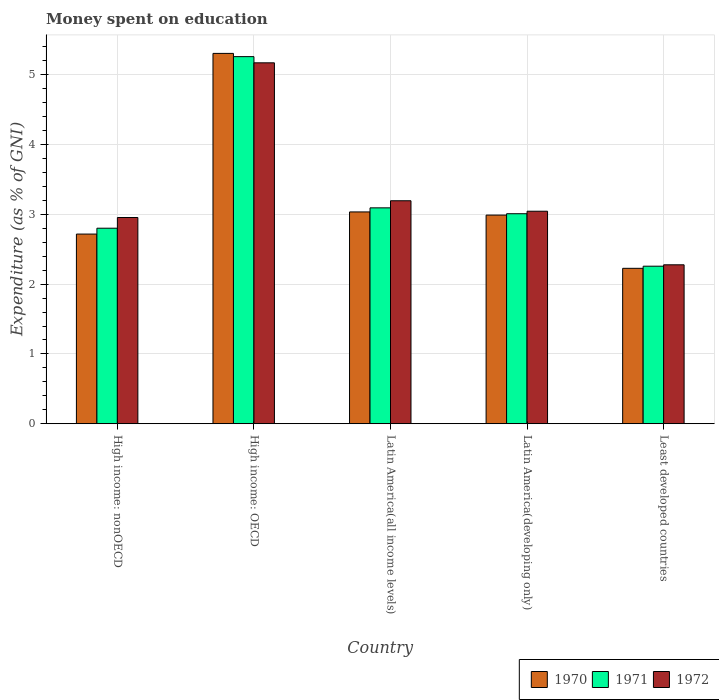How many different coloured bars are there?
Ensure brevity in your answer.  3. How many groups of bars are there?
Give a very brief answer. 5. How many bars are there on the 1st tick from the left?
Provide a succinct answer. 3. How many bars are there on the 3rd tick from the right?
Provide a short and direct response. 3. What is the label of the 1st group of bars from the left?
Provide a short and direct response. High income: nonOECD. What is the amount of money spent on education in 1972 in High income: nonOECD?
Give a very brief answer. 2.96. Across all countries, what is the maximum amount of money spent on education in 1972?
Your answer should be very brief. 5.17. Across all countries, what is the minimum amount of money spent on education in 1972?
Give a very brief answer. 2.28. In which country was the amount of money spent on education in 1972 maximum?
Give a very brief answer. High income: OECD. In which country was the amount of money spent on education in 1970 minimum?
Provide a succinct answer. Least developed countries. What is the total amount of money spent on education in 1971 in the graph?
Your answer should be very brief. 16.42. What is the difference between the amount of money spent on education in 1972 in High income: OECD and that in Latin America(all income levels)?
Your response must be concise. 1.98. What is the difference between the amount of money spent on education in 1972 in Latin America(all income levels) and the amount of money spent on education in 1971 in Least developed countries?
Make the answer very short. 0.94. What is the average amount of money spent on education in 1972 per country?
Provide a succinct answer. 3.33. What is the difference between the amount of money spent on education of/in 1970 and amount of money spent on education of/in 1971 in High income: nonOECD?
Keep it short and to the point. -0.08. In how many countries, is the amount of money spent on education in 1972 greater than 3.2 %?
Ensure brevity in your answer.  1. What is the ratio of the amount of money spent on education in 1972 in High income: OECD to that in Latin America(developing only)?
Your response must be concise. 1.7. Is the amount of money spent on education in 1970 in High income: OECD less than that in High income: nonOECD?
Give a very brief answer. No. What is the difference between the highest and the second highest amount of money spent on education in 1970?
Provide a succinct answer. -0.05. What is the difference between the highest and the lowest amount of money spent on education in 1972?
Offer a terse response. 2.89. In how many countries, is the amount of money spent on education in 1970 greater than the average amount of money spent on education in 1970 taken over all countries?
Offer a terse response. 1. What does the 1st bar from the right in High income: OECD represents?
Keep it short and to the point. 1972. How many bars are there?
Ensure brevity in your answer.  15. How many countries are there in the graph?
Provide a succinct answer. 5. Are the values on the major ticks of Y-axis written in scientific E-notation?
Your answer should be very brief. No. Does the graph contain any zero values?
Give a very brief answer. No. Does the graph contain grids?
Give a very brief answer. Yes. Where does the legend appear in the graph?
Your answer should be compact. Bottom right. How many legend labels are there?
Ensure brevity in your answer.  3. What is the title of the graph?
Provide a short and direct response. Money spent on education. What is the label or title of the Y-axis?
Offer a very short reply. Expenditure (as % of GNI). What is the Expenditure (as % of GNI) in 1970 in High income: nonOECD?
Give a very brief answer. 2.72. What is the Expenditure (as % of GNI) in 1971 in High income: nonOECD?
Your answer should be compact. 2.8. What is the Expenditure (as % of GNI) of 1972 in High income: nonOECD?
Your response must be concise. 2.96. What is the Expenditure (as % of GNI) of 1970 in High income: OECD?
Your answer should be compact. 5.31. What is the Expenditure (as % of GNI) of 1971 in High income: OECD?
Keep it short and to the point. 5.26. What is the Expenditure (as % of GNI) of 1972 in High income: OECD?
Offer a very short reply. 5.17. What is the Expenditure (as % of GNI) in 1970 in Latin America(all income levels)?
Ensure brevity in your answer.  3.04. What is the Expenditure (as % of GNI) in 1971 in Latin America(all income levels)?
Give a very brief answer. 3.09. What is the Expenditure (as % of GNI) of 1972 in Latin America(all income levels)?
Provide a short and direct response. 3.2. What is the Expenditure (as % of GNI) of 1970 in Latin America(developing only)?
Offer a very short reply. 2.99. What is the Expenditure (as % of GNI) in 1971 in Latin America(developing only)?
Provide a succinct answer. 3.01. What is the Expenditure (as % of GNI) in 1972 in Latin America(developing only)?
Keep it short and to the point. 3.05. What is the Expenditure (as % of GNI) in 1970 in Least developed countries?
Give a very brief answer. 2.23. What is the Expenditure (as % of GNI) of 1971 in Least developed countries?
Your answer should be very brief. 2.26. What is the Expenditure (as % of GNI) in 1972 in Least developed countries?
Give a very brief answer. 2.28. Across all countries, what is the maximum Expenditure (as % of GNI) in 1970?
Provide a succinct answer. 5.31. Across all countries, what is the maximum Expenditure (as % of GNI) of 1971?
Your answer should be very brief. 5.26. Across all countries, what is the maximum Expenditure (as % of GNI) in 1972?
Offer a very short reply. 5.17. Across all countries, what is the minimum Expenditure (as % of GNI) in 1970?
Your answer should be compact. 2.23. Across all countries, what is the minimum Expenditure (as % of GNI) of 1971?
Give a very brief answer. 2.26. Across all countries, what is the minimum Expenditure (as % of GNI) in 1972?
Your answer should be compact. 2.28. What is the total Expenditure (as % of GNI) of 1970 in the graph?
Provide a short and direct response. 16.28. What is the total Expenditure (as % of GNI) in 1971 in the graph?
Offer a very short reply. 16.42. What is the total Expenditure (as % of GNI) in 1972 in the graph?
Your response must be concise. 16.64. What is the difference between the Expenditure (as % of GNI) in 1970 in High income: nonOECD and that in High income: OECD?
Your response must be concise. -2.59. What is the difference between the Expenditure (as % of GNI) in 1971 in High income: nonOECD and that in High income: OECD?
Provide a succinct answer. -2.46. What is the difference between the Expenditure (as % of GNI) of 1972 in High income: nonOECD and that in High income: OECD?
Ensure brevity in your answer.  -2.22. What is the difference between the Expenditure (as % of GNI) of 1970 in High income: nonOECD and that in Latin America(all income levels)?
Your answer should be compact. -0.32. What is the difference between the Expenditure (as % of GNI) of 1971 in High income: nonOECD and that in Latin America(all income levels)?
Provide a succinct answer. -0.29. What is the difference between the Expenditure (as % of GNI) in 1972 in High income: nonOECD and that in Latin America(all income levels)?
Offer a very short reply. -0.24. What is the difference between the Expenditure (as % of GNI) in 1970 in High income: nonOECD and that in Latin America(developing only)?
Give a very brief answer. -0.27. What is the difference between the Expenditure (as % of GNI) of 1971 in High income: nonOECD and that in Latin America(developing only)?
Your answer should be compact. -0.21. What is the difference between the Expenditure (as % of GNI) of 1972 in High income: nonOECD and that in Latin America(developing only)?
Your answer should be very brief. -0.09. What is the difference between the Expenditure (as % of GNI) in 1970 in High income: nonOECD and that in Least developed countries?
Offer a very short reply. 0.49. What is the difference between the Expenditure (as % of GNI) in 1971 in High income: nonOECD and that in Least developed countries?
Offer a very short reply. 0.54. What is the difference between the Expenditure (as % of GNI) of 1972 in High income: nonOECD and that in Least developed countries?
Provide a short and direct response. 0.68. What is the difference between the Expenditure (as % of GNI) of 1970 in High income: OECD and that in Latin America(all income levels)?
Provide a short and direct response. 2.27. What is the difference between the Expenditure (as % of GNI) of 1971 in High income: OECD and that in Latin America(all income levels)?
Your answer should be very brief. 2.17. What is the difference between the Expenditure (as % of GNI) of 1972 in High income: OECD and that in Latin America(all income levels)?
Provide a succinct answer. 1.98. What is the difference between the Expenditure (as % of GNI) in 1970 in High income: OECD and that in Latin America(developing only)?
Your answer should be compact. 2.32. What is the difference between the Expenditure (as % of GNI) of 1971 in High income: OECD and that in Latin America(developing only)?
Offer a very short reply. 2.25. What is the difference between the Expenditure (as % of GNI) of 1972 in High income: OECD and that in Latin America(developing only)?
Offer a terse response. 2.13. What is the difference between the Expenditure (as % of GNI) in 1970 in High income: OECD and that in Least developed countries?
Give a very brief answer. 3.08. What is the difference between the Expenditure (as % of GNI) in 1971 in High income: OECD and that in Least developed countries?
Your answer should be compact. 3. What is the difference between the Expenditure (as % of GNI) in 1972 in High income: OECD and that in Least developed countries?
Provide a succinct answer. 2.89. What is the difference between the Expenditure (as % of GNI) in 1970 in Latin America(all income levels) and that in Latin America(developing only)?
Your response must be concise. 0.05. What is the difference between the Expenditure (as % of GNI) of 1971 in Latin America(all income levels) and that in Latin America(developing only)?
Offer a terse response. 0.08. What is the difference between the Expenditure (as % of GNI) in 1972 in Latin America(all income levels) and that in Latin America(developing only)?
Your response must be concise. 0.15. What is the difference between the Expenditure (as % of GNI) in 1970 in Latin America(all income levels) and that in Least developed countries?
Provide a short and direct response. 0.81. What is the difference between the Expenditure (as % of GNI) of 1971 in Latin America(all income levels) and that in Least developed countries?
Provide a short and direct response. 0.84. What is the difference between the Expenditure (as % of GNI) in 1972 in Latin America(all income levels) and that in Least developed countries?
Keep it short and to the point. 0.92. What is the difference between the Expenditure (as % of GNI) of 1970 in Latin America(developing only) and that in Least developed countries?
Give a very brief answer. 0.76. What is the difference between the Expenditure (as % of GNI) in 1971 in Latin America(developing only) and that in Least developed countries?
Make the answer very short. 0.75. What is the difference between the Expenditure (as % of GNI) of 1972 in Latin America(developing only) and that in Least developed countries?
Provide a short and direct response. 0.77. What is the difference between the Expenditure (as % of GNI) in 1970 in High income: nonOECD and the Expenditure (as % of GNI) in 1971 in High income: OECD?
Ensure brevity in your answer.  -2.54. What is the difference between the Expenditure (as % of GNI) of 1970 in High income: nonOECD and the Expenditure (as % of GNI) of 1972 in High income: OECD?
Provide a succinct answer. -2.45. What is the difference between the Expenditure (as % of GNI) in 1971 in High income: nonOECD and the Expenditure (as % of GNI) in 1972 in High income: OECD?
Your response must be concise. -2.37. What is the difference between the Expenditure (as % of GNI) in 1970 in High income: nonOECD and the Expenditure (as % of GNI) in 1971 in Latin America(all income levels)?
Offer a terse response. -0.38. What is the difference between the Expenditure (as % of GNI) of 1970 in High income: nonOECD and the Expenditure (as % of GNI) of 1972 in Latin America(all income levels)?
Your answer should be compact. -0.48. What is the difference between the Expenditure (as % of GNI) in 1971 in High income: nonOECD and the Expenditure (as % of GNI) in 1972 in Latin America(all income levels)?
Provide a succinct answer. -0.39. What is the difference between the Expenditure (as % of GNI) of 1970 in High income: nonOECD and the Expenditure (as % of GNI) of 1971 in Latin America(developing only)?
Make the answer very short. -0.29. What is the difference between the Expenditure (as % of GNI) of 1970 in High income: nonOECD and the Expenditure (as % of GNI) of 1972 in Latin America(developing only)?
Your answer should be very brief. -0.33. What is the difference between the Expenditure (as % of GNI) of 1971 in High income: nonOECD and the Expenditure (as % of GNI) of 1972 in Latin America(developing only)?
Offer a very short reply. -0.24. What is the difference between the Expenditure (as % of GNI) in 1970 in High income: nonOECD and the Expenditure (as % of GNI) in 1971 in Least developed countries?
Ensure brevity in your answer.  0.46. What is the difference between the Expenditure (as % of GNI) of 1970 in High income: nonOECD and the Expenditure (as % of GNI) of 1972 in Least developed countries?
Your answer should be compact. 0.44. What is the difference between the Expenditure (as % of GNI) of 1971 in High income: nonOECD and the Expenditure (as % of GNI) of 1972 in Least developed countries?
Make the answer very short. 0.52. What is the difference between the Expenditure (as % of GNI) of 1970 in High income: OECD and the Expenditure (as % of GNI) of 1971 in Latin America(all income levels)?
Your answer should be very brief. 2.21. What is the difference between the Expenditure (as % of GNI) in 1970 in High income: OECD and the Expenditure (as % of GNI) in 1972 in Latin America(all income levels)?
Your answer should be very brief. 2.11. What is the difference between the Expenditure (as % of GNI) in 1971 in High income: OECD and the Expenditure (as % of GNI) in 1972 in Latin America(all income levels)?
Make the answer very short. 2.07. What is the difference between the Expenditure (as % of GNI) of 1970 in High income: OECD and the Expenditure (as % of GNI) of 1971 in Latin America(developing only)?
Your response must be concise. 2.3. What is the difference between the Expenditure (as % of GNI) in 1970 in High income: OECD and the Expenditure (as % of GNI) in 1972 in Latin America(developing only)?
Offer a very short reply. 2.26. What is the difference between the Expenditure (as % of GNI) in 1971 in High income: OECD and the Expenditure (as % of GNI) in 1972 in Latin America(developing only)?
Keep it short and to the point. 2.22. What is the difference between the Expenditure (as % of GNI) in 1970 in High income: OECD and the Expenditure (as % of GNI) in 1971 in Least developed countries?
Your answer should be very brief. 3.05. What is the difference between the Expenditure (as % of GNI) in 1970 in High income: OECD and the Expenditure (as % of GNI) in 1972 in Least developed countries?
Keep it short and to the point. 3.03. What is the difference between the Expenditure (as % of GNI) of 1971 in High income: OECD and the Expenditure (as % of GNI) of 1972 in Least developed countries?
Make the answer very short. 2.98. What is the difference between the Expenditure (as % of GNI) of 1970 in Latin America(all income levels) and the Expenditure (as % of GNI) of 1971 in Latin America(developing only)?
Your answer should be very brief. 0.03. What is the difference between the Expenditure (as % of GNI) in 1970 in Latin America(all income levels) and the Expenditure (as % of GNI) in 1972 in Latin America(developing only)?
Offer a very short reply. -0.01. What is the difference between the Expenditure (as % of GNI) of 1971 in Latin America(all income levels) and the Expenditure (as % of GNI) of 1972 in Latin America(developing only)?
Offer a very short reply. 0.05. What is the difference between the Expenditure (as % of GNI) of 1970 in Latin America(all income levels) and the Expenditure (as % of GNI) of 1971 in Least developed countries?
Give a very brief answer. 0.78. What is the difference between the Expenditure (as % of GNI) in 1970 in Latin America(all income levels) and the Expenditure (as % of GNI) in 1972 in Least developed countries?
Provide a succinct answer. 0.76. What is the difference between the Expenditure (as % of GNI) in 1971 in Latin America(all income levels) and the Expenditure (as % of GNI) in 1972 in Least developed countries?
Keep it short and to the point. 0.82. What is the difference between the Expenditure (as % of GNI) in 1970 in Latin America(developing only) and the Expenditure (as % of GNI) in 1971 in Least developed countries?
Your response must be concise. 0.73. What is the difference between the Expenditure (as % of GNI) in 1970 in Latin America(developing only) and the Expenditure (as % of GNI) in 1972 in Least developed countries?
Make the answer very short. 0.71. What is the difference between the Expenditure (as % of GNI) of 1971 in Latin America(developing only) and the Expenditure (as % of GNI) of 1972 in Least developed countries?
Provide a short and direct response. 0.73. What is the average Expenditure (as % of GNI) of 1970 per country?
Provide a short and direct response. 3.26. What is the average Expenditure (as % of GNI) in 1971 per country?
Keep it short and to the point. 3.28. What is the average Expenditure (as % of GNI) of 1972 per country?
Give a very brief answer. 3.33. What is the difference between the Expenditure (as % of GNI) of 1970 and Expenditure (as % of GNI) of 1971 in High income: nonOECD?
Make the answer very short. -0.08. What is the difference between the Expenditure (as % of GNI) in 1970 and Expenditure (as % of GNI) in 1972 in High income: nonOECD?
Your response must be concise. -0.24. What is the difference between the Expenditure (as % of GNI) of 1971 and Expenditure (as % of GNI) of 1972 in High income: nonOECD?
Ensure brevity in your answer.  -0.15. What is the difference between the Expenditure (as % of GNI) of 1970 and Expenditure (as % of GNI) of 1971 in High income: OECD?
Your answer should be very brief. 0.05. What is the difference between the Expenditure (as % of GNI) of 1970 and Expenditure (as % of GNI) of 1972 in High income: OECD?
Provide a succinct answer. 0.14. What is the difference between the Expenditure (as % of GNI) in 1971 and Expenditure (as % of GNI) in 1972 in High income: OECD?
Keep it short and to the point. 0.09. What is the difference between the Expenditure (as % of GNI) in 1970 and Expenditure (as % of GNI) in 1971 in Latin America(all income levels)?
Your answer should be compact. -0.06. What is the difference between the Expenditure (as % of GNI) of 1970 and Expenditure (as % of GNI) of 1972 in Latin America(all income levels)?
Make the answer very short. -0.16. What is the difference between the Expenditure (as % of GNI) in 1971 and Expenditure (as % of GNI) in 1972 in Latin America(all income levels)?
Give a very brief answer. -0.1. What is the difference between the Expenditure (as % of GNI) in 1970 and Expenditure (as % of GNI) in 1971 in Latin America(developing only)?
Give a very brief answer. -0.02. What is the difference between the Expenditure (as % of GNI) in 1970 and Expenditure (as % of GNI) in 1972 in Latin America(developing only)?
Ensure brevity in your answer.  -0.06. What is the difference between the Expenditure (as % of GNI) in 1971 and Expenditure (as % of GNI) in 1972 in Latin America(developing only)?
Ensure brevity in your answer.  -0.04. What is the difference between the Expenditure (as % of GNI) of 1970 and Expenditure (as % of GNI) of 1971 in Least developed countries?
Your response must be concise. -0.03. What is the difference between the Expenditure (as % of GNI) of 1970 and Expenditure (as % of GNI) of 1972 in Least developed countries?
Your response must be concise. -0.05. What is the difference between the Expenditure (as % of GNI) of 1971 and Expenditure (as % of GNI) of 1972 in Least developed countries?
Provide a succinct answer. -0.02. What is the ratio of the Expenditure (as % of GNI) of 1970 in High income: nonOECD to that in High income: OECD?
Ensure brevity in your answer.  0.51. What is the ratio of the Expenditure (as % of GNI) of 1971 in High income: nonOECD to that in High income: OECD?
Make the answer very short. 0.53. What is the ratio of the Expenditure (as % of GNI) in 1970 in High income: nonOECD to that in Latin America(all income levels)?
Your answer should be compact. 0.9. What is the ratio of the Expenditure (as % of GNI) in 1971 in High income: nonOECD to that in Latin America(all income levels)?
Offer a terse response. 0.91. What is the ratio of the Expenditure (as % of GNI) of 1972 in High income: nonOECD to that in Latin America(all income levels)?
Offer a very short reply. 0.92. What is the ratio of the Expenditure (as % of GNI) of 1970 in High income: nonOECD to that in Latin America(developing only)?
Make the answer very short. 0.91. What is the ratio of the Expenditure (as % of GNI) of 1971 in High income: nonOECD to that in Latin America(developing only)?
Keep it short and to the point. 0.93. What is the ratio of the Expenditure (as % of GNI) in 1972 in High income: nonOECD to that in Latin America(developing only)?
Offer a terse response. 0.97. What is the ratio of the Expenditure (as % of GNI) of 1970 in High income: nonOECD to that in Least developed countries?
Your response must be concise. 1.22. What is the ratio of the Expenditure (as % of GNI) of 1971 in High income: nonOECD to that in Least developed countries?
Give a very brief answer. 1.24. What is the ratio of the Expenditure (as % of GNI) in 1972 in High income: nonOECD to that in Least developed countries?
Offer a very short reply. 1.3. What is the ratio of the Expenditure (as % of GNI) in 1970 in High income: OECD to that in Latin America(all income levels)?
Your answer should be very brief. 1.75. What is the ratio of the Expenditure (as % of GNI) of 1971 in High income: OECD to that in Latin America(all income levels)?
Keep it short and to the point. 1.7. What is the ratio of the Expenditure (as % of GNI) in 1972 in High income: OECD to that in Latin America(all income levels)?
Provide a succinct answer. 1.62. What is the ratio of the Expenditure (as % of GNI) of 1970 in High income: OECD to that in Latin America(developing only)?
Provide a short and direct response. 1.77. What is the ratio of the Expenditure (as % of GNI) of 1971 in High income: OECD to that in Latin America(developing only)?
Offer a very short reply. 1.75. What is the ratio of the Expenditure (as % of GNI) in 1972 in High income: OECD to that in Latin America(developing only)?
Your response must be concise. 1.7. What is the ratio of the Expenditure (as % of GNI) of 1970 in High income: OECD to that in Least developed countries?
Offer a terse response. 2.38. What is the ratio of the Expenditure (as % of GNI) in 1971 in High income: OECD to that in Least developed countries?
Offer a very short reply. 2.33. What is the ratio of the Expenditure (as % of GNI) in 1972 in High income: OECD to that in Least developed countries?
Keep it short and to the point. 2.27. What is the ratio of the Expenditure (as % of GNI) in 1970 in Latin America(all income levels) to that in Latin America(developing only)?
Give a very brief answer. 1.02. What is the ratio of the Expenditure (as % of GNI) of 1971 in Latin America(all income levels) to that in Latin America(developing only)?
Provide a succinct answer. 1.03. What is the ratio of the Expenditure (as % of GNI) in 1972 in Latin America(all income levels) to that in Latin America(developing only)?
Your response must be concise. 1.05. What is the ratio of the Expenditure (as % of GNI) in 1970 in Latin America(all income levels) to that in Least developed countries?
Ensure brevity in your answer.  1.36. What is the ratio of the Expenditure (as % of GNI) of 1971 in Latin America(all income levels) to that in Least developed countries?
Offer a terse response. 1.37. What is the ratio of the Expenditure (as % of GNI) of 1972 in Latin America(all income levels) to that in Least developed countries?
Keep it short and to the point. 1.4. What is the ratio of the Expenditure (as % of GNI) in 1970 in Latin America(developing only) to that in Least developed countries?
Keep it short and to the point. 1.34. What is the ratio of the Expenditure (as % of GNI) in 1971 in Latin America(developing only) to that in Least developed countries?
Make the answer very short. 1.33. What is the ratio of the Expenditure (as % of GNI) of 1972 in Latin America(developing only) to that in Least developed countries?
Make the answer very short. 1.34. What is the difference between the highest and the second highest Expenditure (as % of GNI) of 1970?
Make the answer very short. 2.27. What is the difference between the highest and the second highest Expenditure (as % of GNI) of 1971?
Give a very brief answer. 2.17. What is the difference between the highest and the second highest Expenditure (as % of GNI) in 1972?
Offer a terse response. 1.98. What is the difference between the highest and the lowest Expenditure (as % of GNI) in 1970?
Provide a succinct answer. 3.08. What is the difference between the highest and the lowest Expenditure (as % of GNI) in 1971?
Give a very brief answer. 3. What is the difference between the highest and the lowest Expenditure (as % of GNI) in 1972?
Keep it short and to the point. 2.89. 